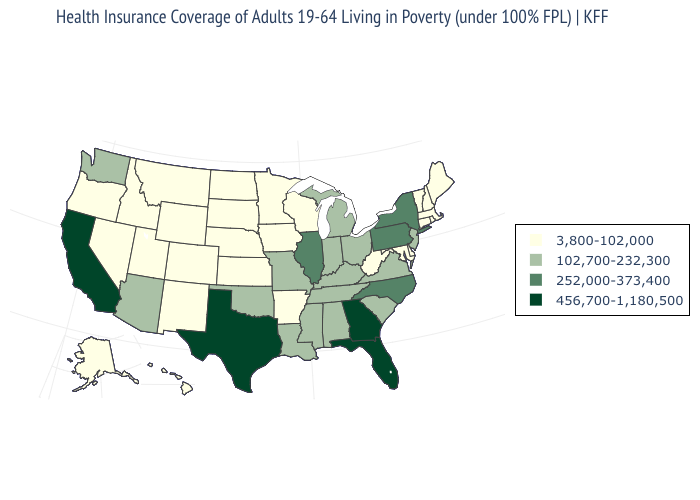What is the value of New Jersey?
Short answer required. 102,700-232,300. Name the states that have a value in the range 102,700-232,300?
Concise answer only. Alabama, Arizona, Indiana, Kentucky, Louisiana, Michigan, Mississippi, Missouri, New Jersey, Ohio, Oklahoma, South Carolina, Tennessee, Virginia, Washington. Does Georgia have the lowest value in the USA?
Write a very short answer. No. Among the states that border Indiana , which have the lowest value?
Short answer required. Kentucky, Michigan, Ohio. What is the value of New Jersey?
Be succinct. 102,700-232,300. What is the lowest value in the USA?
Be succinct. 3,800-102,000. What is the highest value in the USA?
Quick response, please. 456,700-1,180,500. What is the value of Missouri?
Short answer required. 102,700-232,300. Does Maryland have the highest value in the South?
Quick response, please. No. Which states hav the highest value in the West?
Quick response, please. California. What is the lowest value in the Northeast?
Be succinct. 3,800-102,000. Does Minnesota have the highest value in the MidWest?
Write a very short answer. No. Name the states that have a value in the range 3,800-102,000?
Answer briefly. Alaska, Arkansas, Colorado, Connecticut, Delaware, Hawaii, Idaho, Iowa, Kansas, Maine, Maryland, Massachusetts, Minnesota, Montana, Nebraska, Nevada, New Hampshire, New Mexico, North Dakota, Oregon, Rhode Island, South Dakota, Utah, Vermont, West Virginia, Wisconsin, Wyoming. Among the states that border Virginia , does North Carolina have the lowest value?
Short answer required. No. What is the lowest value in states that border Maine?
Short answer required. 3,800-102,000. 